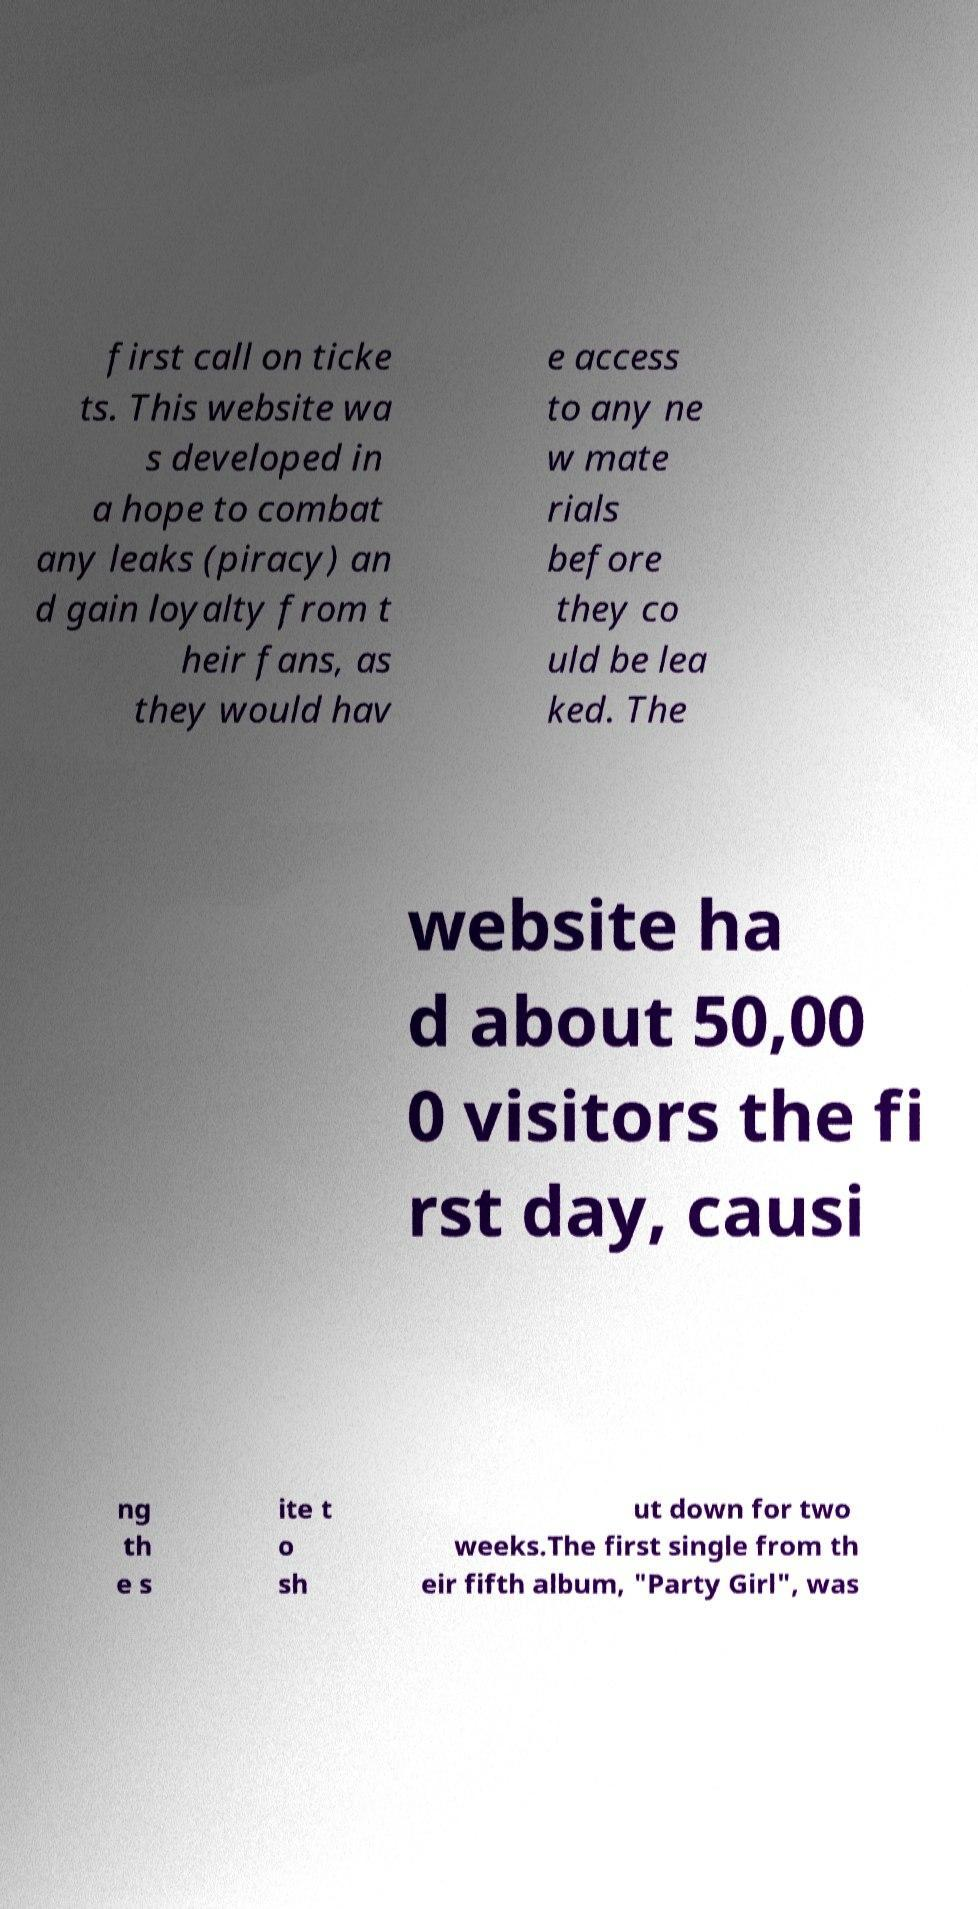Can you read and provide the text displayed in the image?This photo seems to have some interesting text. Can you extract and type it out for me? first call on ticke ts. This website wa s developed in a hope to combat any leaks (piracy) an d gain loyalty from t heir fans, as they would hav e access to any ne w mate rials before they co uld be lea ked. The website ha d about 50,00 0 visitors the fi rst day, causi ng th e s ite t o sh ut down for two weeks.The first single from th eir fifth album, "Party Girl", was 